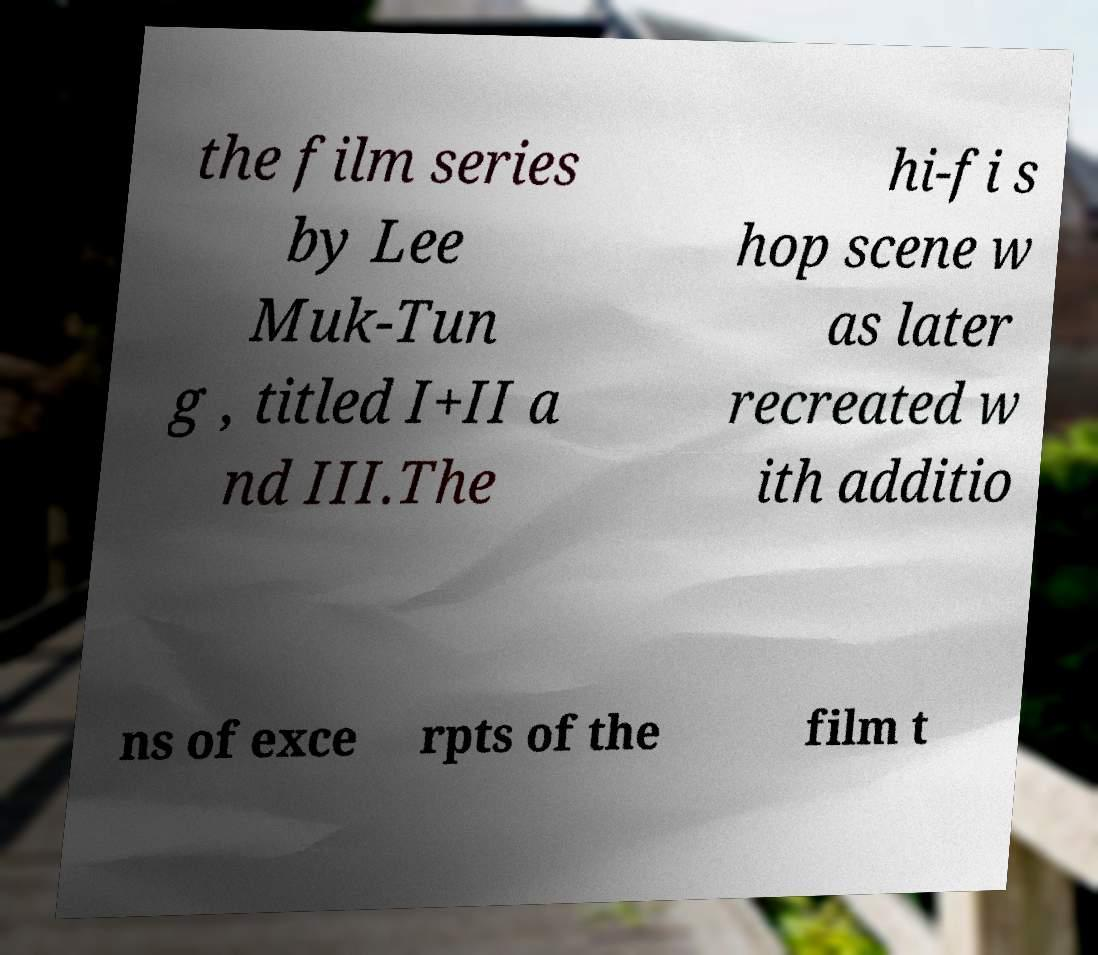Please identify and transcribe the text found in this image. the film series by Lee Muk-Tun g , titled I+II a nd III.The hi-fi s hop scene w as later recreated w ith additio ns of exce rpts of the film t 